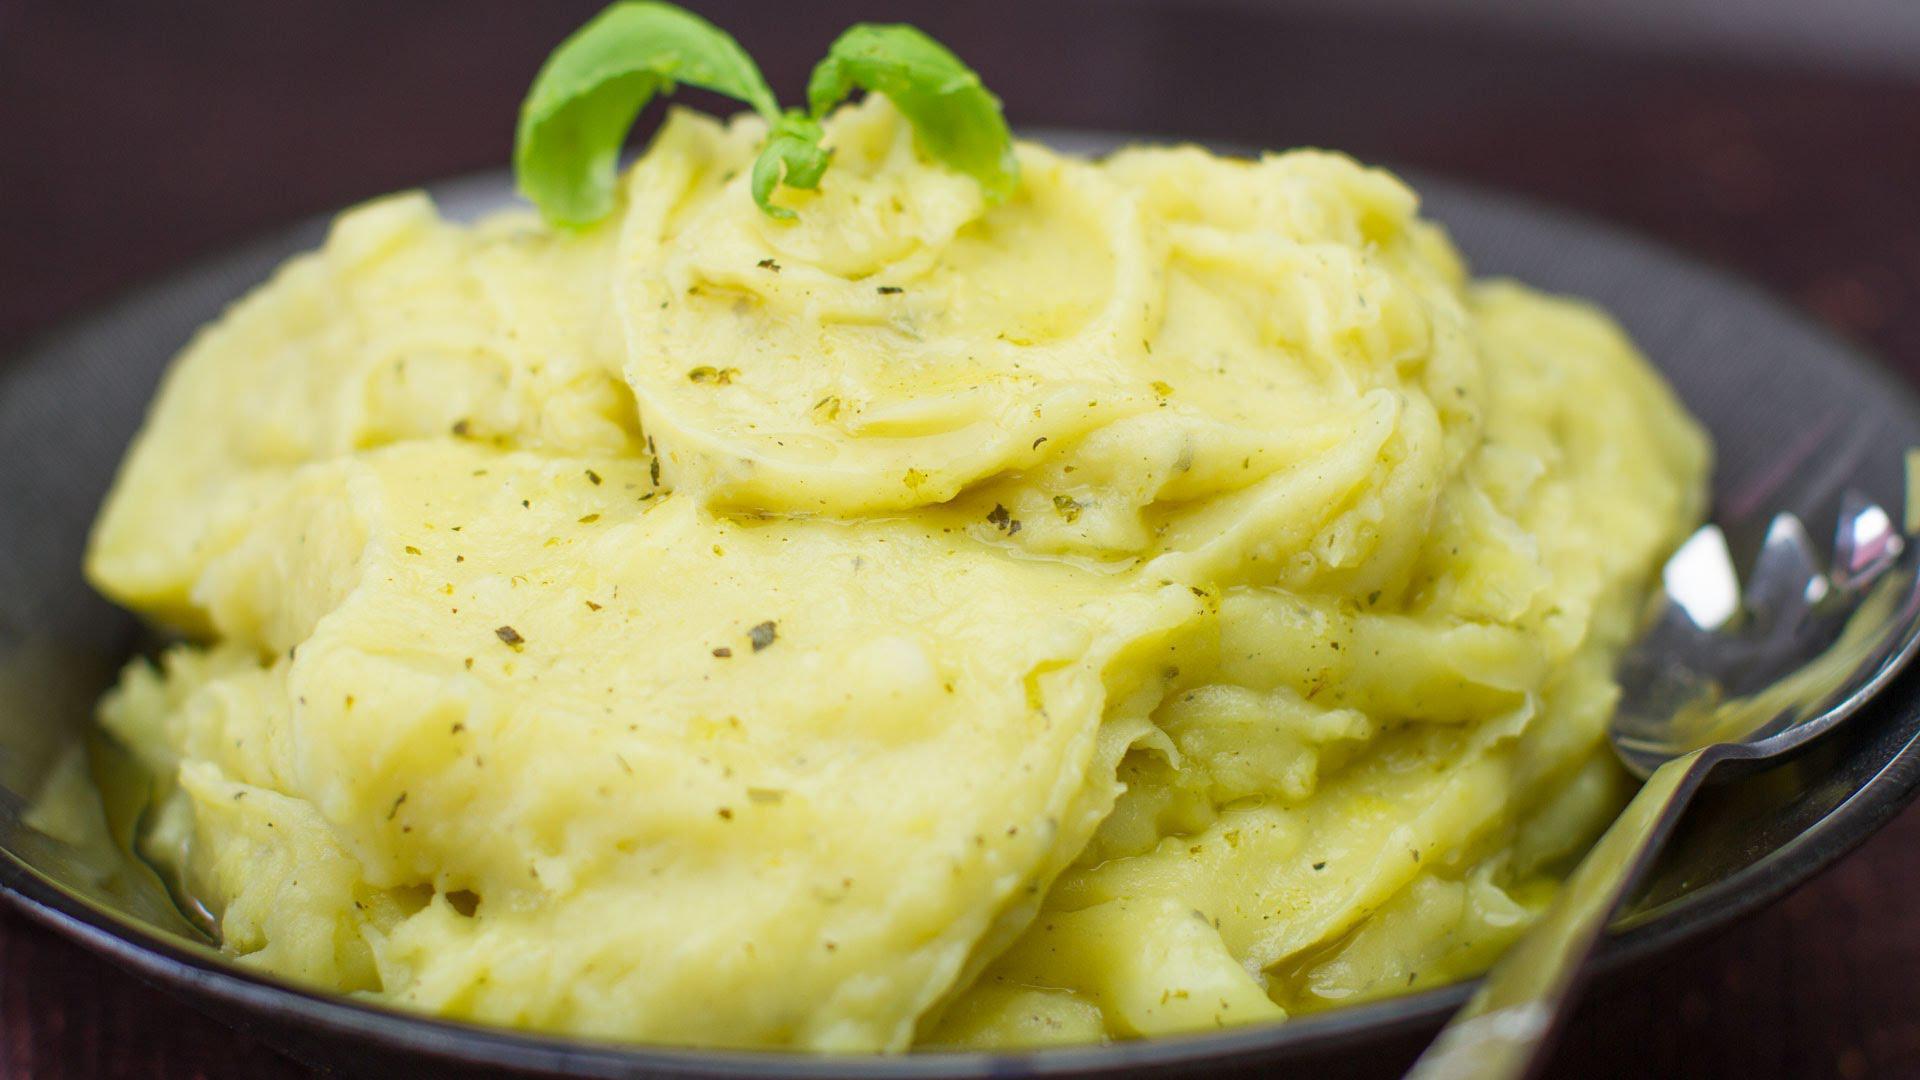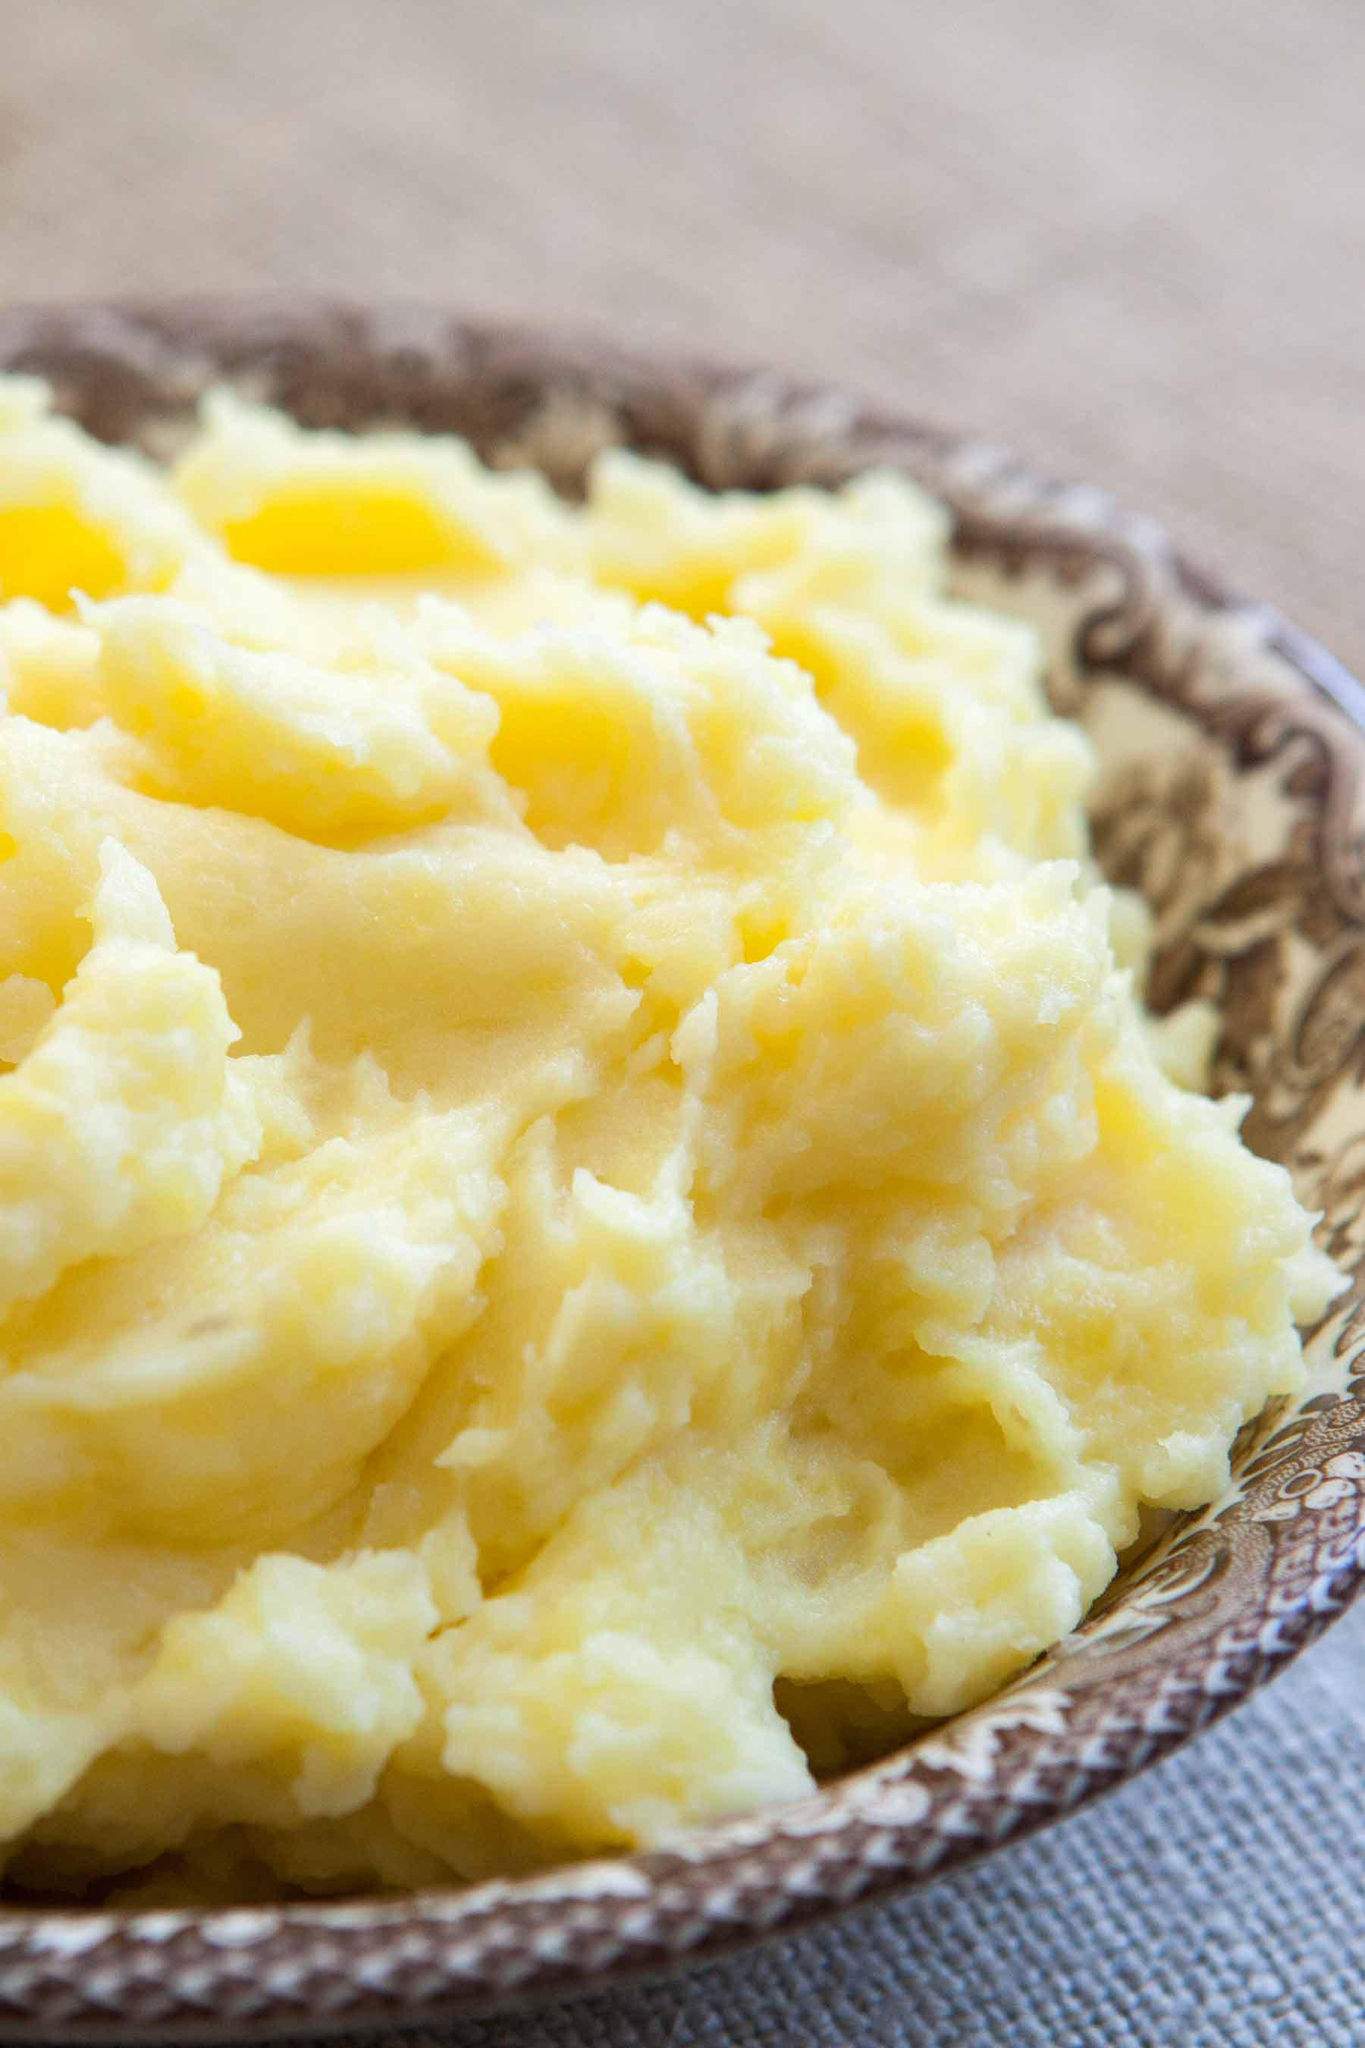The first image is the image on the left, the second image is the image on the right. Considering the images on both sides, is "There is a spoon in the food on the right, but not on the left." valid? Answer yes or no. No. 